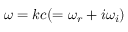<formula> <loc_0><loc_0><loc_500><loc_500>\omega = k c ( = \omega _ { r } + i \omega _ { i } )</formula> 